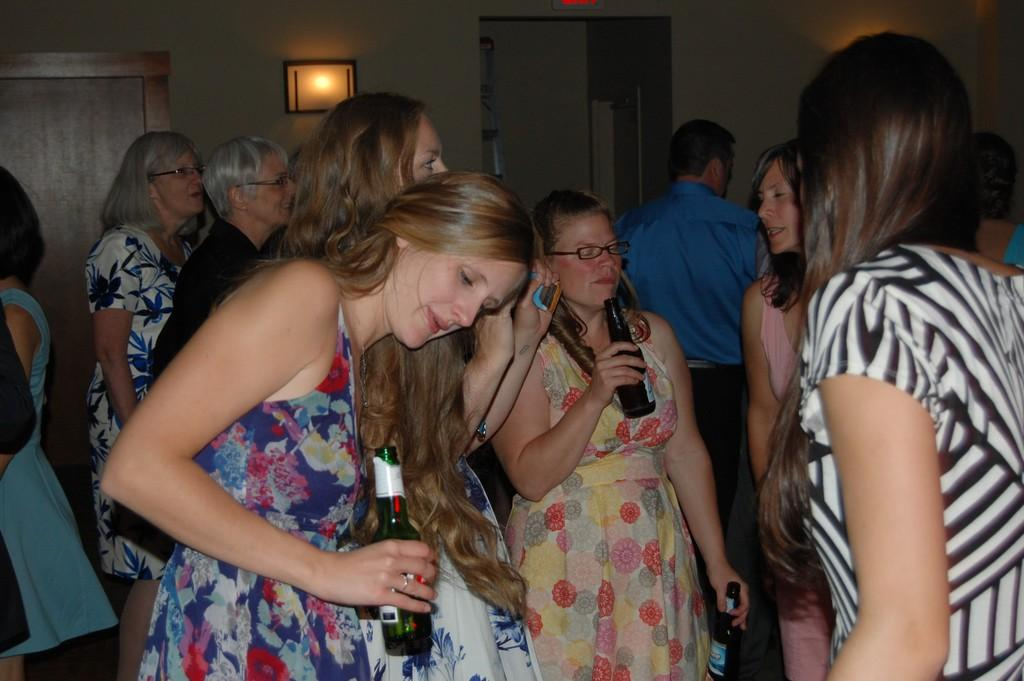What are the people in the image doing? The people in the image are standing. What objects are some people holding? Some people are holding bottles. What architectural features can be seen in the image? There are doors and a wall in the image. What can be used to provide illumination in the image? There are lights in the image. What type of fruit is being used as a punishment in the image? There is no fruit or punishment present in the image. 